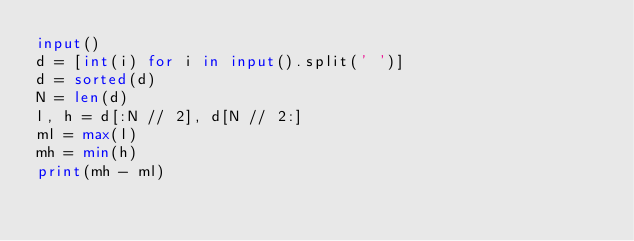Convert code to text. <code><loc_0><loc_0><loc_500><loc_500><_Python_>input()
d = [int(i) for i in input().split(' ')]
d = sorted(d)
N = len(d)
l, h = d[:N // 2], d[N // 2:]
ml = max(l)
mh = min(h)
print(mh - ml)
</code> 